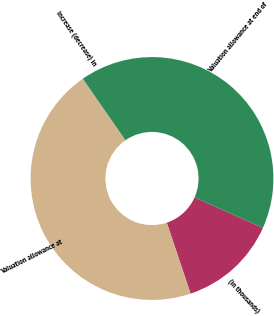<chart> <loc_0><loc_0><loc_500><loc_500><pie_chart><fcel>(in thousands)<fcel>Valuation allowance at<fcel>Increase (decrease) in<fcel>Valuation allowance at end of<nl><fcel>13.19%<fcel>45.44%<fcel>0.05%<fcel>41.31%<nl></chart> 